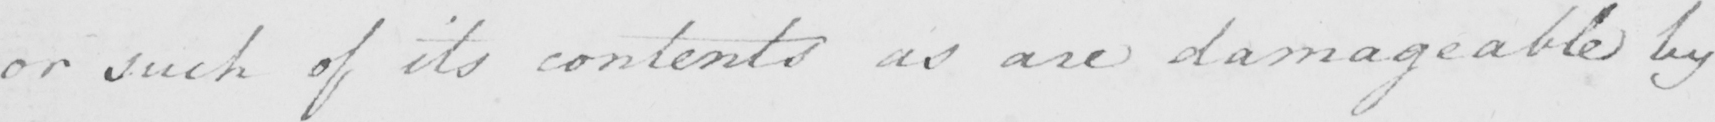Can you read and transcribe this handwriting? or such of its contents as are damageable by 